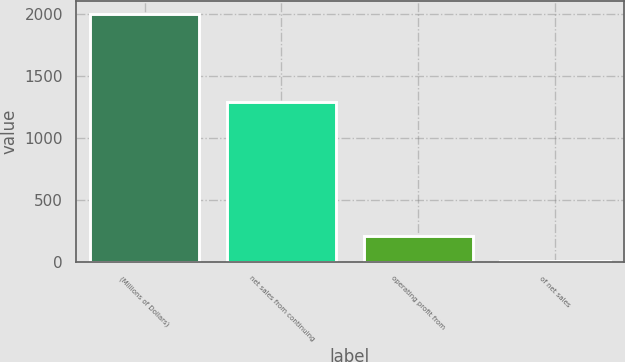Convert chart. <chart><loc_0><loc_0><loc_500><loc_500><bar_chart><fcel>(Millions of Dollars)<fcel>net sales from continuing<fcel>operating profit from<fcel>of net sales<nl><fcel>2004<fcel>1293<fcel>209.67<fcel>10.3<nl></chart> 